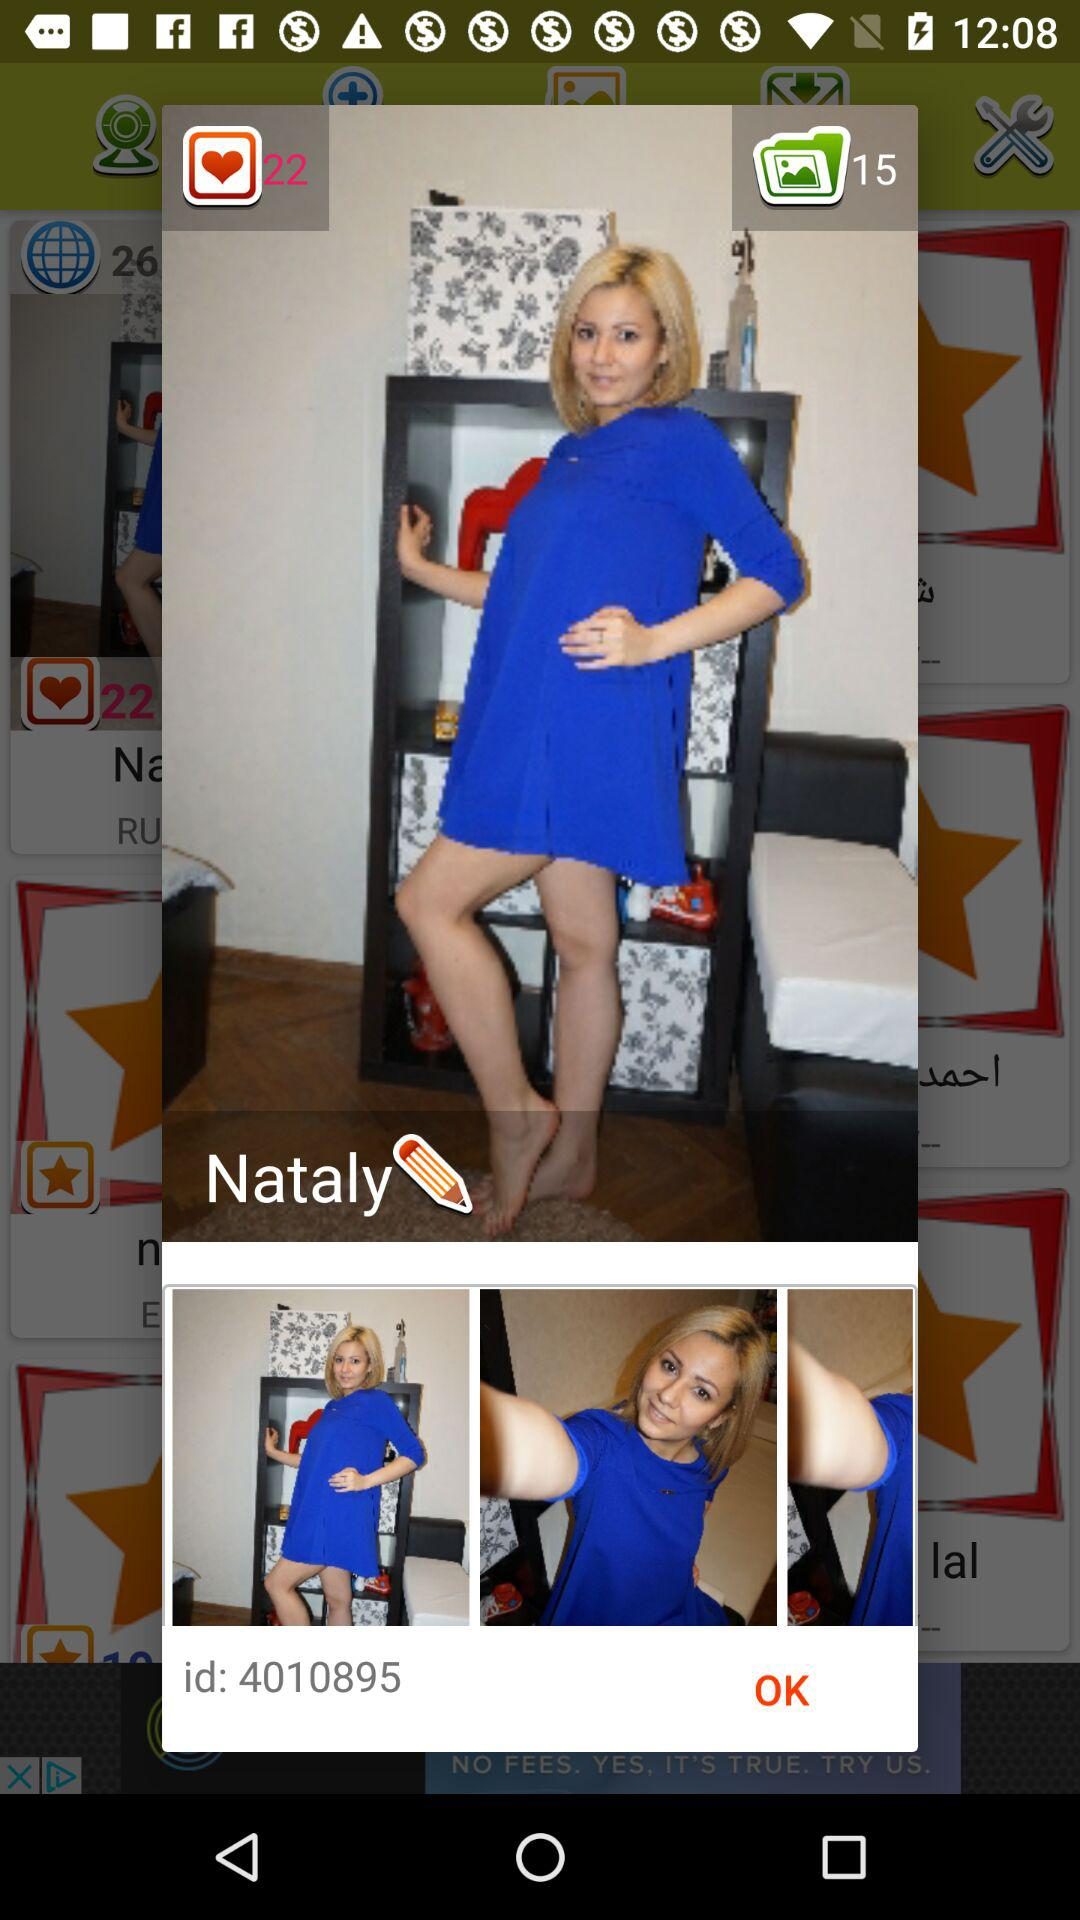What is the name of the person? The name of the person is Nataly. 